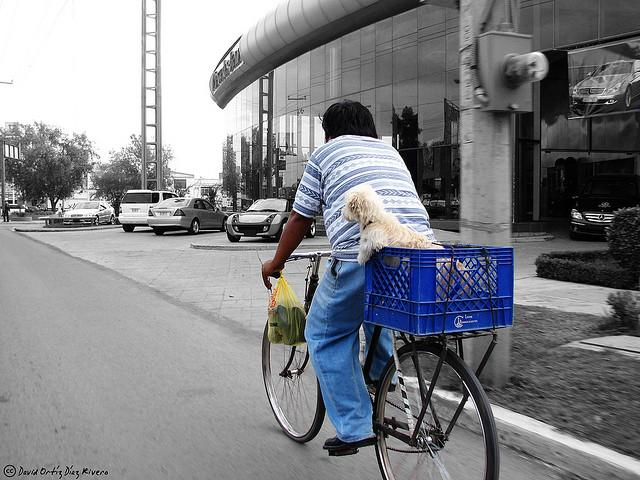Why is there a car poster on the building? Please explain your reasoning. advertisement. The poster on the building is to display one of the models that someone can buy if they are shopping for a car. 